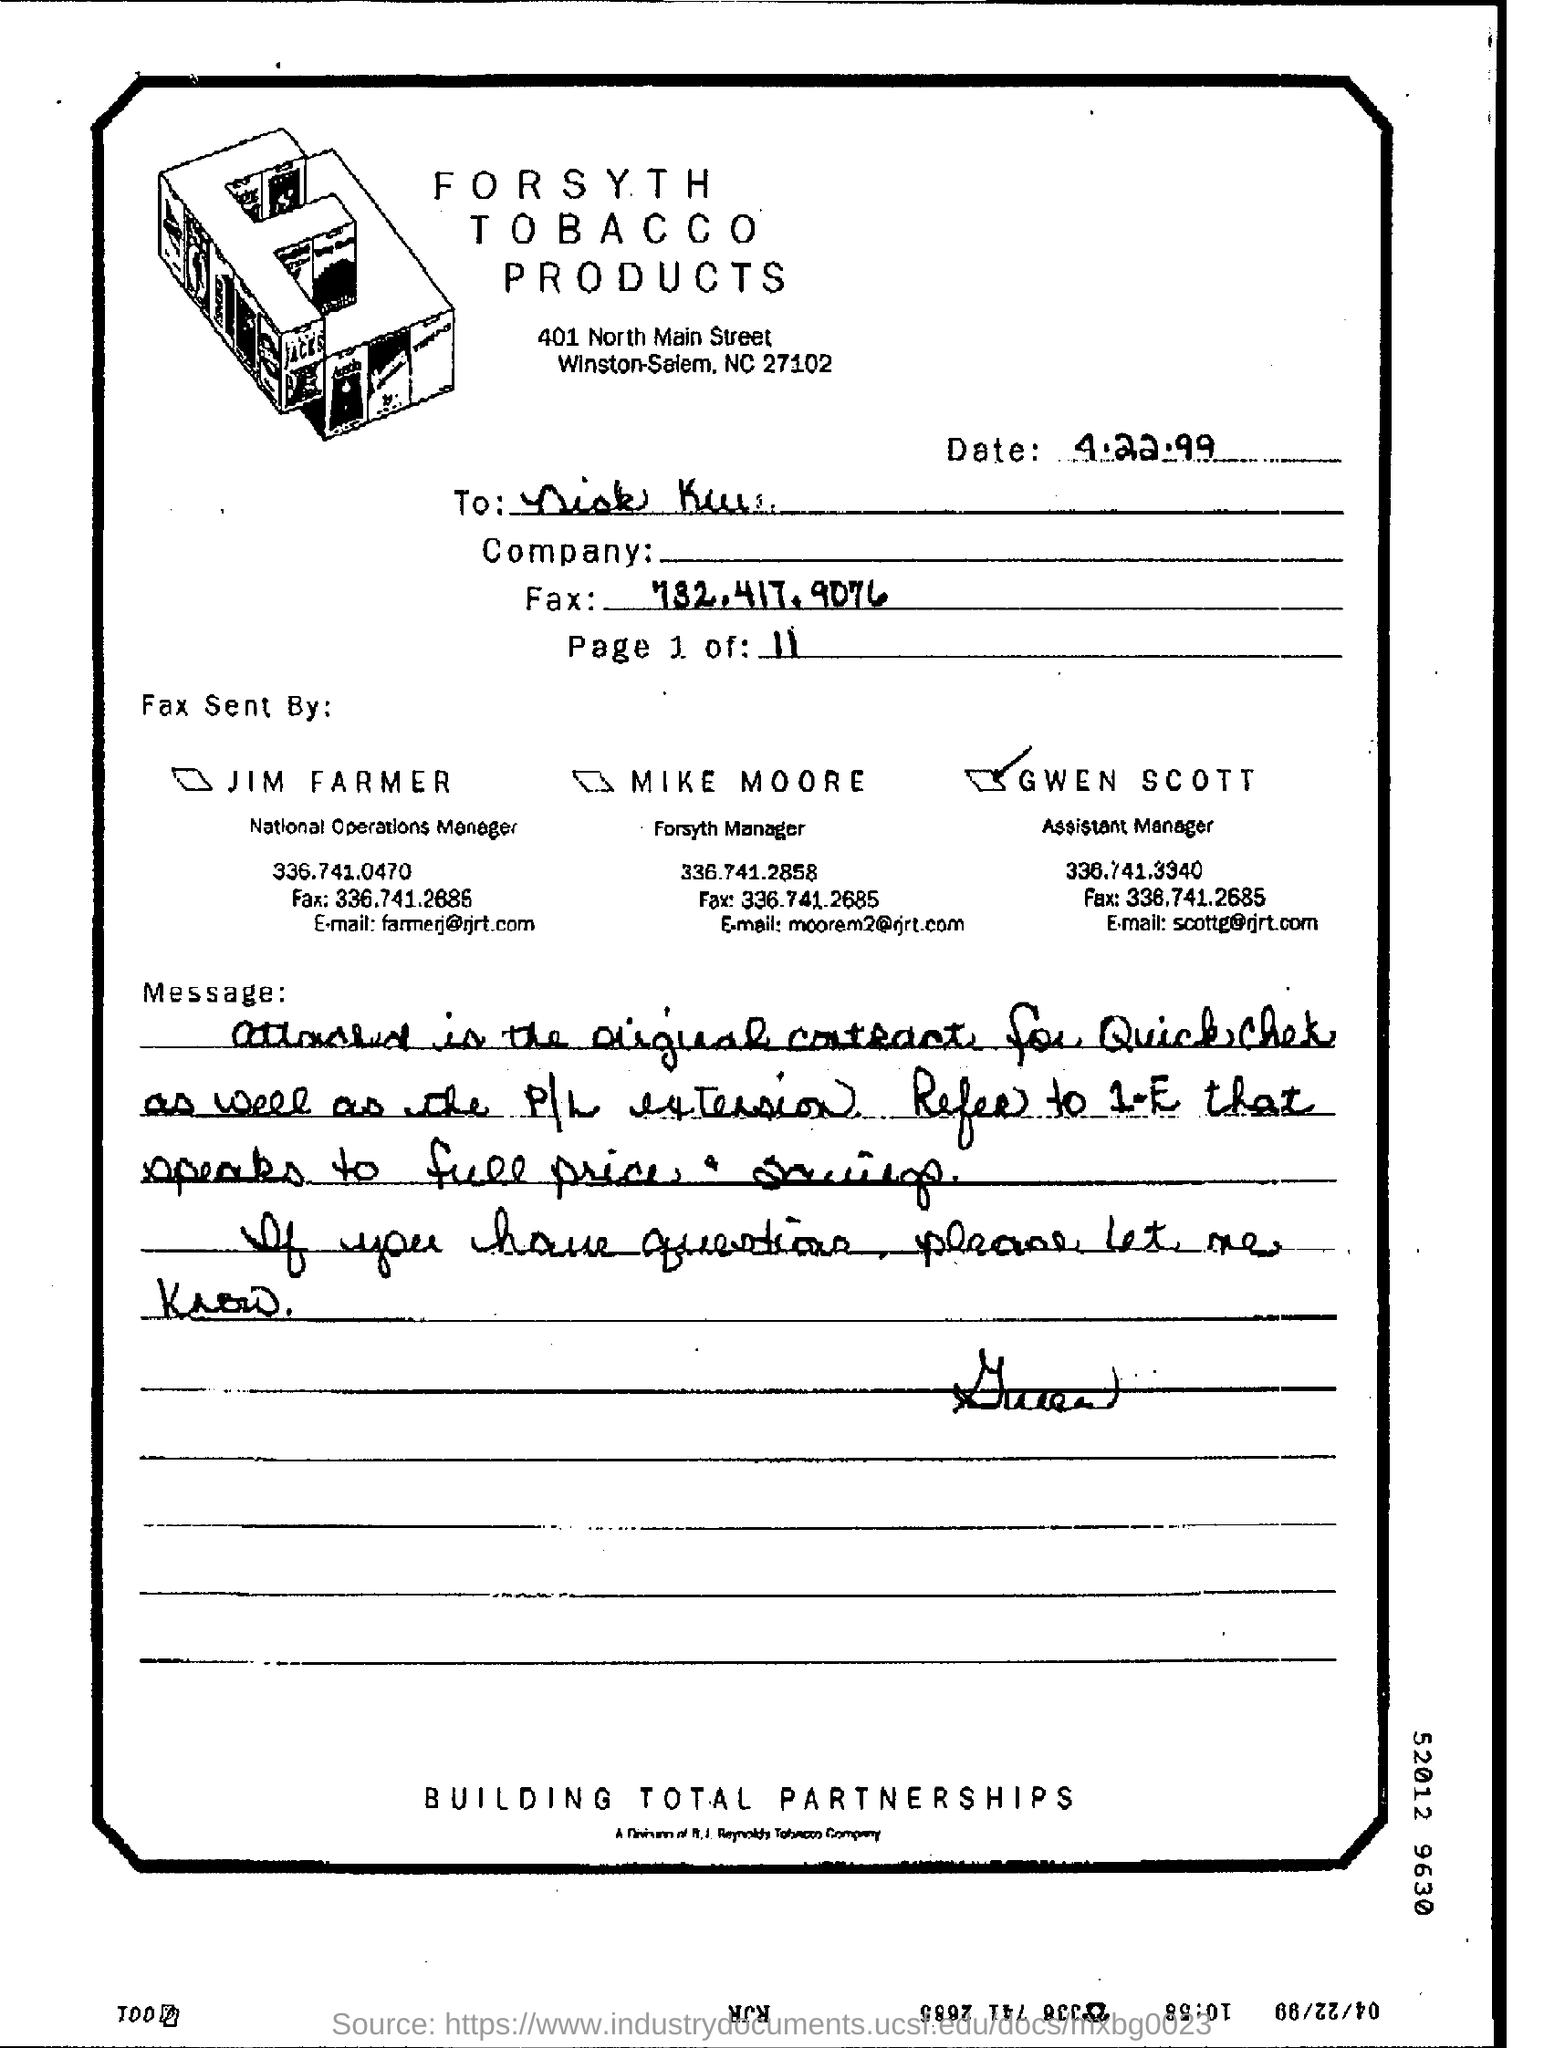Specify some key components in this picture. The date mentioned at the top of the document is 4.22.99. 